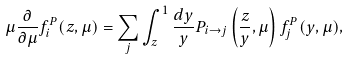Convert formula to latex. <formula><loc_0><loc_0><loc_500><loc_500>\mu \frac { \partial } { \partial \mu } f ^ { P } _ { i } ( z , \mu ) = \sum _ { j } \int ^ { 1 } _ { z } \frac { d y } { y } P _ { i \rightarrow j } \left ( \frac { z } { y } , \mu \right ) f ^ { P } _ { j } ( y , \mu ) ,</formula> 